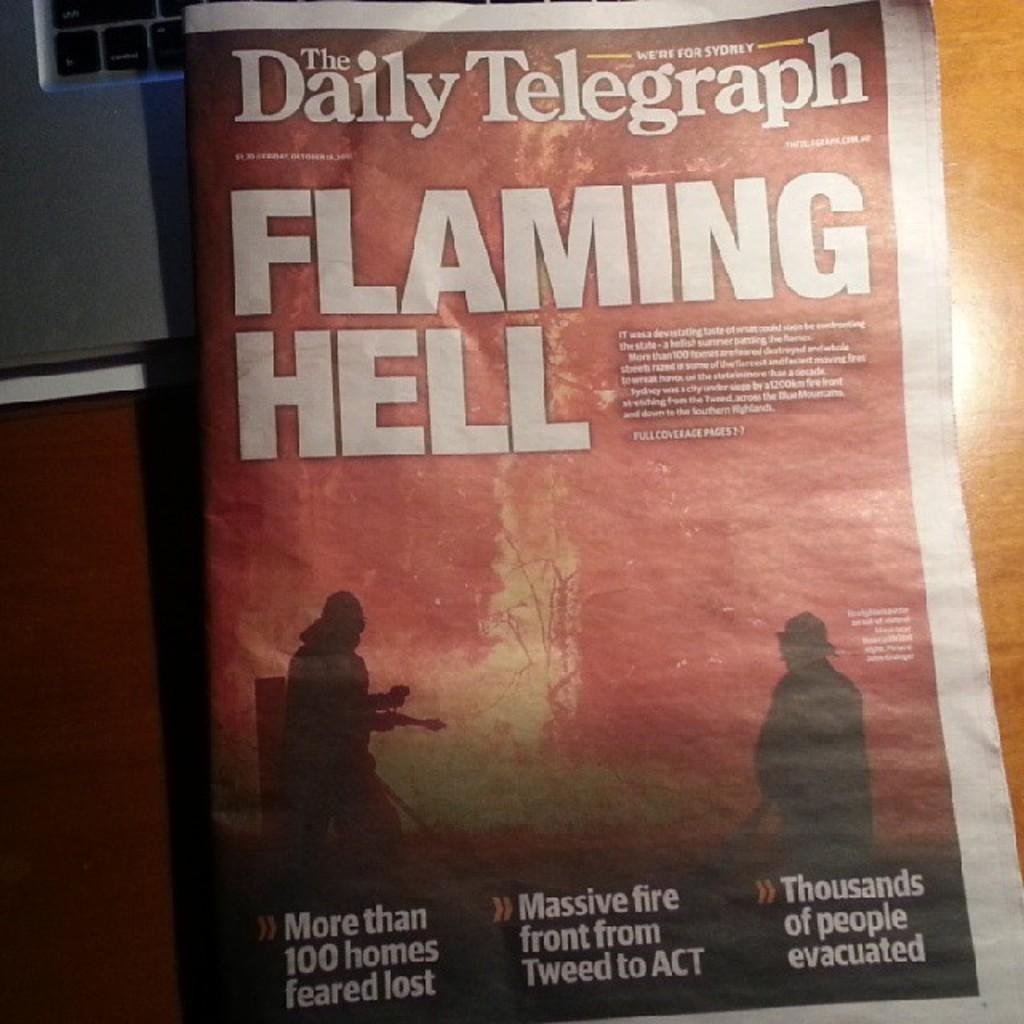Provide a one-sentence caption for the provided image. A copy of the Daily Telegraph features a story titled "Flaming Hell.". 